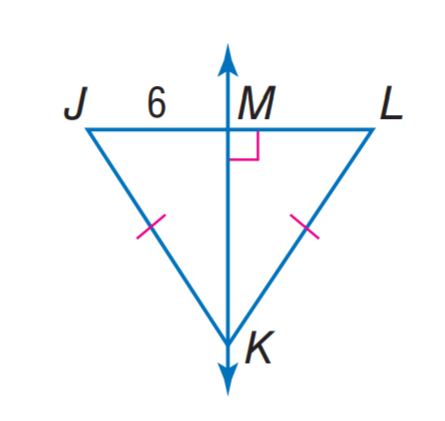Answer the mathemtical geometry problem and directly provide the correct option letter.
Question: Find J L.
Choices: A: 3 B: 6 C: 12 D: 24 C 